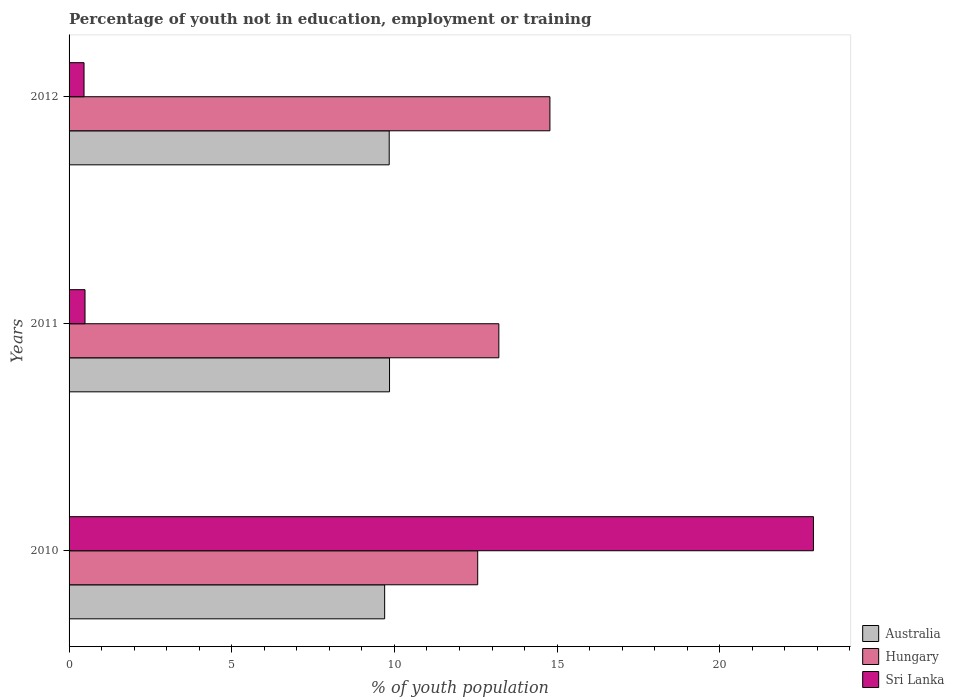How many groups of bars are there?
Ensure brevity in your answer.  3. Are the number of bars per tick equal to the number of legend labels?
Provide a short and direct response. Yes. Are the number of bars on each tick of the Y-axis equal?
Provide a succinct answer. Yes. What is the label of the 2nd group of bars from the top?
Your answer should be very brief. 2011. What is the percentage of unemployed youth population in in Sri Lanka in 2012?
Keep it short and to the point. 0.46. Across all years, what is the maximum percentage of unemployed youth population in in Australia?
Ensure brevity in your answer.  9.85. Across all years, what is the minimum percentage of unemployed youth population in in Sri Lanka?
Your answer should be compact. 0.46. In which year was the percentage of unemployed youth population in in Australia minimum?
Your response must be concise. 2010. What is the total percentage of unemployed youth population in in Hungary in the graph?
Your answer should be very brief. 40.55. What is the difference between the percentage of unemployed youth population in in Australia in 2010 and that in 2011?
Your answer should be compact. -0.15. What is the difference between the percentage of unemployed youth population in in Sri Lanka in 2010 and the percentage of unemployed youth population in in Australia in 2011?
Give a very brief answer. 13.03. What is the average percentage of unemployed youth population in in Australia per year?
Ensure brevity in your answer.  9.8. In the year 2011, what is the difference between the percentage of unemployed youth population in in Australia and percentage of unemployed youth population in in Sri Lanka?
Provide a short and direct response. 9.36. In how many years, is the percentage of unemployed youth population in in Australia greater than 10 %?
Provide a short and direct response. 0. What is the ratio of the percentage of unemployed youth population in in Sri Lanka in 2010 to that in 2012?
Ensure brevity in your answer.  49.74. Is the percentage of unemployed youth population in in Hungary in 2011 less than that in 2012?
Keep it short and to the point. Yes. What is the difference between the highest and the second highest percentage of unemployed youth population in in Australia?
Provide a short and direct response. 0.01. What is the difference between the highest and the lowest percentage of unemployed youth population in in Australia?
Make the answer very short. 0.15. In how many years, is the percentage of unemployed youth population in in Australia greater than the average percentage of unemployed youth population in in Australia taken over all years?
Offer a terse response. 2. Is the sum of the percentage of unemployed youth population in in Hungary in 2010 and 2012 greater than the maximum percentage of unemployed youth population in in Sri Lanka across all years?
Make the answer very short. Yes. What does the 2nd bar from the top in 2011 represents?
Give a very brief answer. Hungary. What does the 2nd bar from the bottom in 2011 represents?
Give a very brief answer. Hungary. Is it the case that in every year, the sum of the percentage of unemployed youth population in in Sri Lanka and percentage of unemployed youth population in in Hungary is greater than the percentage of unemployed youth population in in Australia?
Give a very brief answer. Yes. How many years are there in the graph?
Your response must be concise. 3. Are the values on the major ticks of X-axis written in scientific E-notation?
Offer a very short reply. No. Does the graph contain any zero values?
Give a very brief answer. No. Does the graph contain grids?
Provide a short and direct response. No. How many legend labels are there?
Ensure brevity in your answer.  3. What is the title of the graph?
Ensure brevity in your answer.  Percentage of youth not in education, employment or training. Does "United States" appear as one of the legend labels in the graph?
Keep it short and to the point. No. What is the label or title of the X-axis?
Provide a succinct answer. % of youth population. What is the label or title of the Y-axis?
Keep it short and to the point. Years. What is the % of youth population in Australia in 2010?
Provide a short and direct response. 9.7. What is the % of youth population of Hungary in 2010?
Your answer should be very brief. 12.56. What is the % of youth population in Sri Lanka in 2010?
Your answer should be compact. 22.88. What is the % of youth population in Australia in 2011?
Give a very brief answer. 9.85. What is the % of youth population in Hungary in 2011?
Provide a succinct answer. 13.21. What is the % of youth population in Sri Lanka in 2011?
Provide a short and direct response. 0.49. What is the % of youth population in Australia in 2012?
Ensure brevity in your answer.  9.84. What is the % of youth population in Hungary in 2012?
Your answer should be compact. 14.78. What is the % of youth population of Sri Lanka in 2012?
Offer a very short reply. 0.46. Across all years, what is the maximum % of youth population in Australia?
Your response must be concise. 9.85. Across all years, what is the maximum % of youth population of Hungary?
Your answer should be very brief. 14.78. Across all years, what is the maximum % of youth population in Sri Lanka?
Make the answer very short. 22.88. Across all years, what is the minimum % of youth population in Australia?
Your response must be concise. 9.7. Across all years, what is the minimum % of youth population of Hungary?
Your response must be concise. 12.56. Across all years, what is the minimum % of youth population of Sri Lanka?
Keep it short and to the point. 0.46. What is the total % of youth population in Australia in the graph?
Give a very brief answer. 29.39. What is the total % of youth population of Hungary in the graph?
Keep it short and to the point. 40.55. What is the total % of youth population in Sri Lanka in the graph?
Your answer should be compact. 23.83. What is the difference between the % of youth population of Hungary in 2010 and that in 2011?
Keep it short and to the point. -0.65. What is the difference between the % of youth population in Sri Lanka in 2010 and that in 2011?
Provide a short and direct response. 22.39. What is the difference between the % of youth population of Australia in 2010 and that in 2012?
Provide a succinct answer. -0.14. What is the difference between the % of youth population of Hungary in 2010 and that in 2012?
Offer a very short reply. -2.22. What is the difference between the % of youth population in Sri Lanka in 2010 and that in 2012?
Offer a very short reply. 22.42. What is the difference between the % of youth population of Hungary in 2011 and that in 2012?
Give a very brief answer. -1.57. What is the difference between the % of youth population of Sri Lanka in 2011 and that in 2012?
Provide a short and direct response. 0.03. What is the difference between the % of youth population in Australia in 2010 and the % of youth population in Hungary in 2011?
Provide a succinct answer. -3.51. What is the difference between the % of youth population in Australia in 2010 and the % of youth population in Sri Lanka in 2011?
Your answer should be very brief. 9.21. What is the difference between the % of youth population in Hungary in 2010 and the % of youth population in Sri Lanka in 2011?
Offer a very short reply. 12.07. What is the difference between the % of youth population of Australia in 2010 and the % of youth population of Hungary in 2012?
Make the answer very short. -5.08. What is the difference between the % of youth population in Australia in 2010 and the % of youth population in Sri Lanka in 2012?
Your answer should be very brief. 9.24. What is the difference between the % of youth population in Australia in 2011 and the % of youth population in Hungary in 2012?
Offer a terse response. -4.93. What is the difference between the % of youth population in Australia in 2011 and the % of youth population in Sri Lanka in 2012?
Your response must be concise. 9.39. What is the difference between the % of youth population in Hungary in 2011 and the % of youth population in Sri Lanka in 2012?
Offer a very short reply. 12.75. What is the average % of youth population of Australia per year?
Provide a short and direct response. 9.8. What is the average % of youth population of Hungary per year?
Give a very brief answer. 13.52. What is the average % of youth population of Sri Lanka per year?
Provide a short and direct response. 7.94. In the year 2010, what is the difference between the % of youth population in Australia and % of youth population in Hungary?
Your answer should be compact. -2.86. In the year 2010, what is the difference between the % of youth population of Australia and % of youth population of Sri Lanka?
Provide a short and direct response. -13.18. In the year 2010, what is the difference between the % of youth population of Hungary and % of youth population of Sri Lanka?
Your answer should be very brief. -10.32. In the year 2011, what is the difference between the % of youth population of Australia and % of youth population of Hungary?
Ensure brevity in your answer.  -3.36. In the year 2011, what is the difference between the % of youth population of Australia and % of youth population of Sri Lanka?
Offer a very short reply. 9.36. In the year 2011, what is the difference between the % of youth population in Hungary and % of youth population in Sri Lanka?
Offer a terse response. 12.72. In the year 2012, what is the difference between the % of youth population in Australia and % of youth population in Hungary?
Offer a very short reply. -4.94. In the year 2012, what is the difference between the % of youth population in Australia and % of youth population in Sri Lanka?
Give a very brief answer. 9.38. In the year 2012, what is the difference between the % of youth population of Hungary and % of youth population of Sri Lanka?
Your response must be concise. 14.32. What is the ratio of the % of youth population in Hungary in 2010 to that in 2011?
Your answer should be compact. 0.95. What is the ratio of the % of youth population of Sri Lanka in 2010 to that in 2011?
Provide a short and direct response. 46.69. What is the ratio of the % of youth population in Australia in 2010 to that in 2012?
Ensure brevity in your answer.  0.99. What is the ratio of the % of youth population of Hungary in 2010 to that in 2012?
Provide a short and direct response. 0.85. What is the ratio of the % of youth population of Sri Lanka in 2010 to that in 2012?
Offer a very short reply. 49.74. What is the ratio of the % of youth population of Australia in 2011 to that in 2012?
Ensure brevity in your answer.  1. What is the ratio of the % of youth population of Hungary in 2011 to that in 2012?
Make the answer very short. 0.89. What is the ratio of the % of youth population in Sri Lanka in 2011 to that in 2012?
Your answer should be compact. 1.07. What is the difference between the highest and the second highest % of youth population of Australia?
Keep it short and to the point. 0.01. What is the difference between the highest and the second highest % of youth population in Hungary?
Keep it short and to the point. 1.57. What is the difference between the highest and the second highest % of youth population in Sri Lanka?
Provide a short and direct response. 22.39. What is the difference between the highest and the lowest % of youth population in Hungary?
Your answer should be very brief. 2.22. What is the difference between the highest and the lowest % of youth population of Sri Lanka?
Your answer should be very brief. 22.42. 